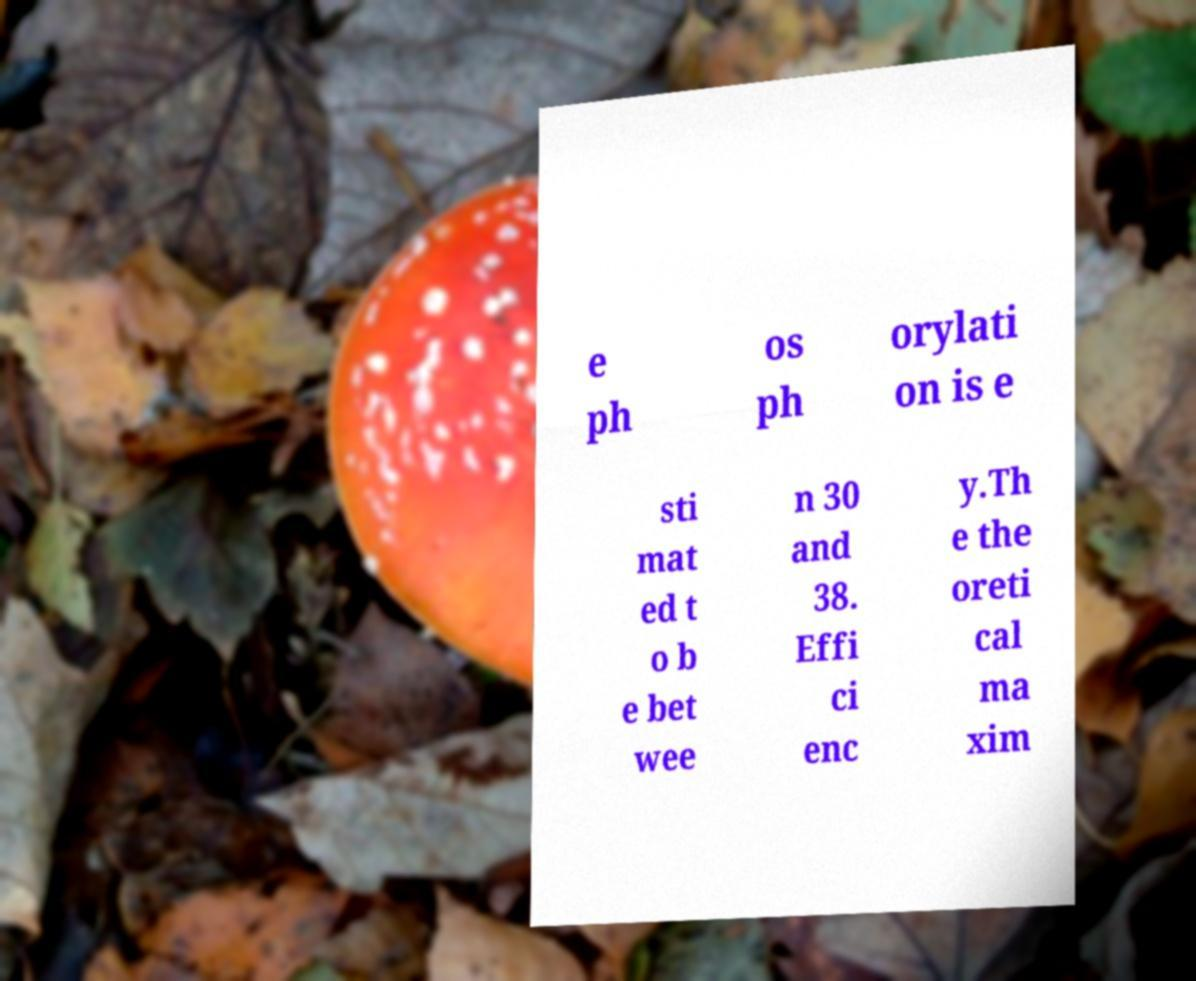Can you accurately transcribe the text from the provided image for me? e ph os ph orylati on is e sti mat ed t o b e bet wee n 30 and 38. Effi ci enc y.Th e the oreti cal ma xim 